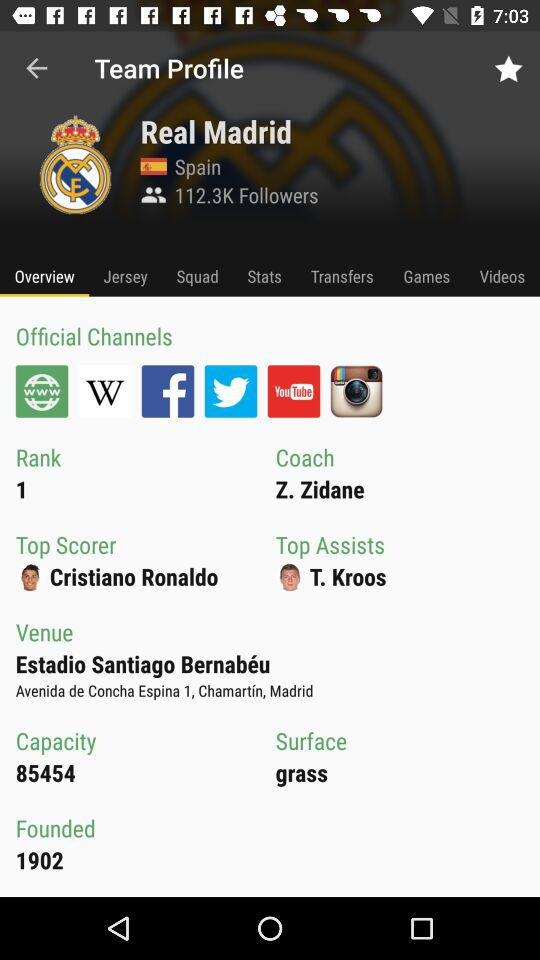How many followers are there for "Real Madrid"? There are 112.3K followers. 